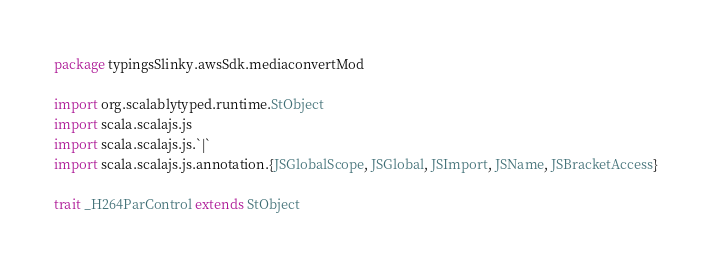Convert code to text. <code><loc_0><loc_0><loc_500><loc_500><_Scala_>package typingsSlinky.awsSdk.mediaconvertMod

import org.scalablytyped.runtime.StObject
import scala.scalajs.js
import scala.scalajs.js.`|`
import scala.scalajs.js.annotation.{JSGlobalScope, JSGlobal, JSImport, JSName, JSBracketAccess}

trait _H264ParControl extends StObject
</code> 